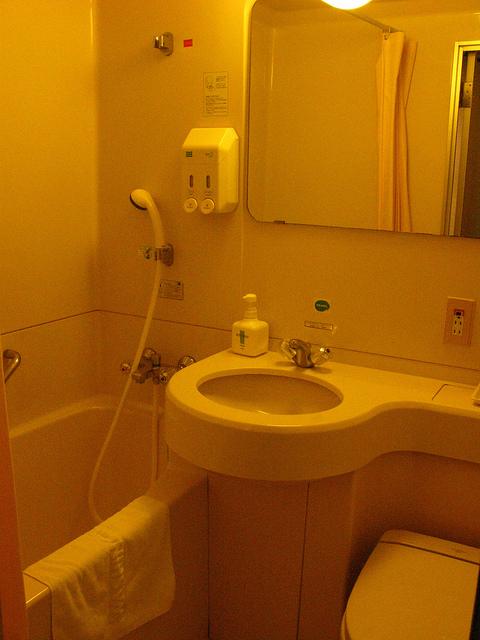Is this a hands free sink?
Concise answer only. No. What is between the bathtub and the toilet?
Concise answer only. Sink. Is that a hand held shower head?
Answer briefly. Yes. What room is this?
Short answer required. Bathroom. 